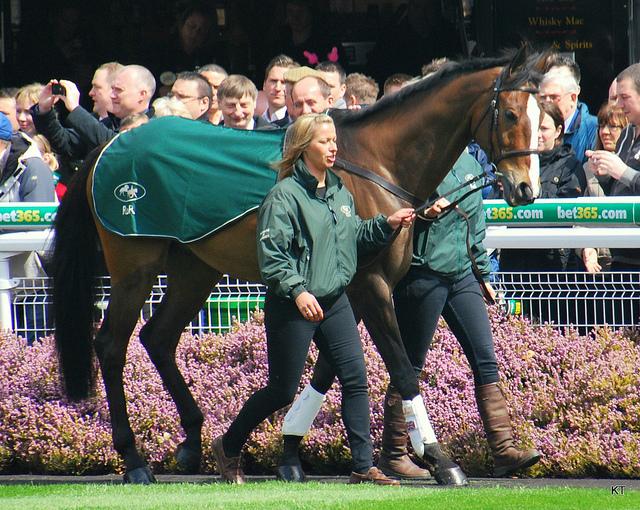What animal is this?
Write a very short answer. Horse. Is the horse wearing a coat?
Be succinct. Yes. What color hair does the woman walking have?
Write a very short answer. Blonde. 